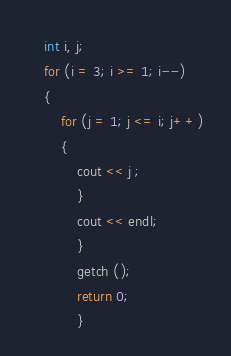<code> <loc_0><loc_0><loc_500><loc_500><_C++_>    int i, j;
    for (i = 3; i >= 1; i--)
    {
        for (j = 1; j <= i; j++)
        {
            cout << j ;
            }
            cout << endl;
            }
            getch ();
            return 0;
            }
</code> 